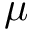Convert formula to latex. <formula><loc_0><loc_0><loc_500><loc_500>\mu</formula> 